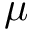Convert formula to latex. <formula><loc_0><loc_0><loc_500><loc_500>\mu</formula> 